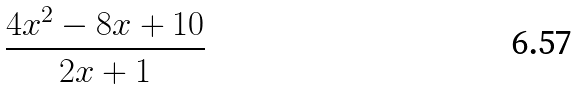<formula> <loc_0><loc_0><loc_500><loc_500>\frac { 4 x ^ { 2 } - 8 x + 1 0 } { 2 x + 1 }</formula> 